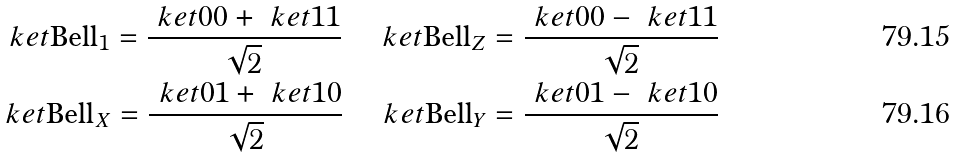<formula> <loc_0><loc_0><loc_500><loc_500>\ k e t { \text {Bell} _ { 1 } } = \frac { \ k e t { 0 0 } + \ k e t { 1 1 } } { \sqrt { 2 } } \quad \ k e t { \text {Bell} _ { Z } } = \frac { \ k e t { 0 0 } - \ k e t { 1 1 } } { \sqrt { 2 } } \\ \ k e t { \text {Bell} _ { X } } = \frac { \ k e t { 0 1 } + \ k e t { 1 0 } } { \sqrt { 2 } } \quad \ k e t { \text {Bell} _ { Y } } = \frac { \ k e t { 0 1 } - \ k e t { 1 0 } } { \sqrt { 2 } }</formula> 